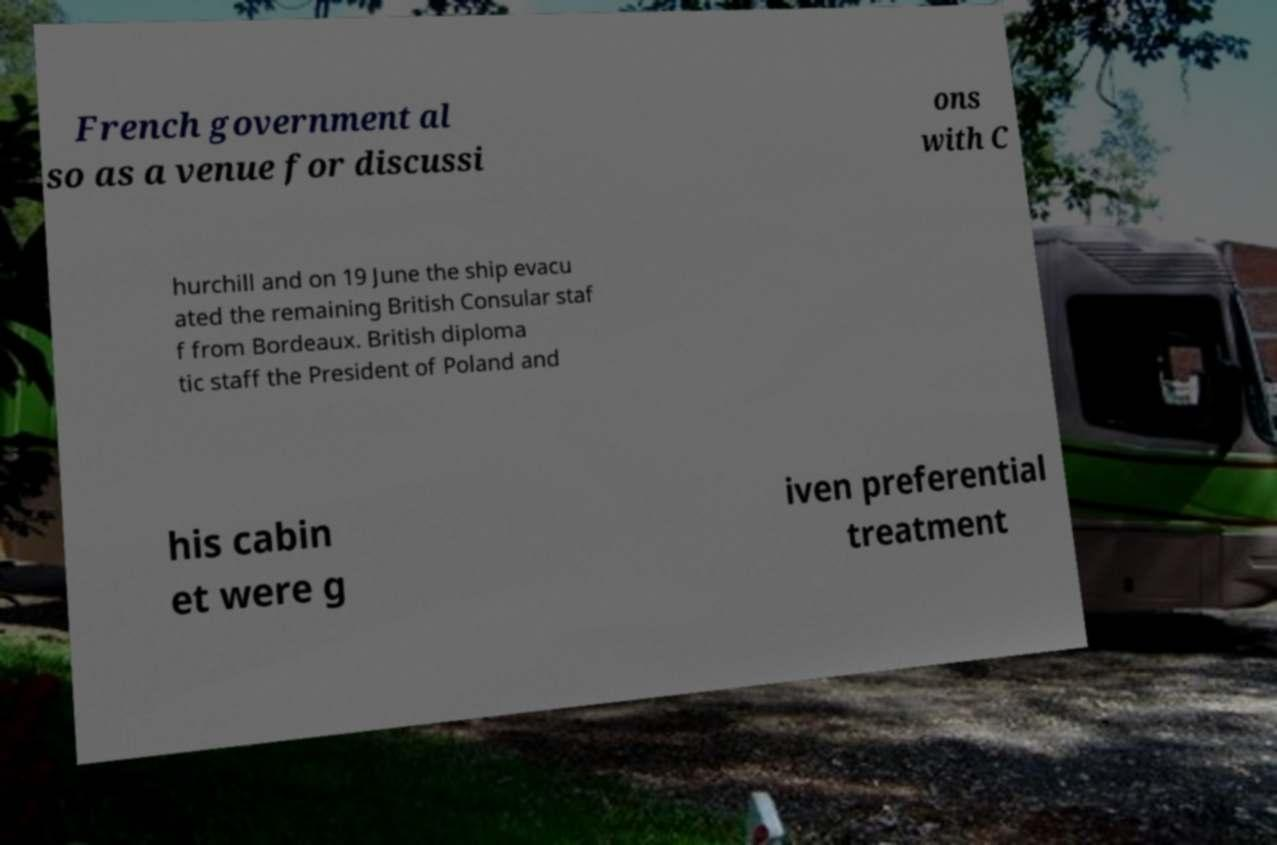Can you read and provide the text displayed in the image?This photo seems to have some interesting text. Can you extract and type it out for me? French government al so as a venue for discussi ons with C hurchill and on 19 June the ship evacu ated the remaining British Consular staf f from Bordeaux. British diploma tic staff the President of Poland and his cabin et were g iven preferential treatment 